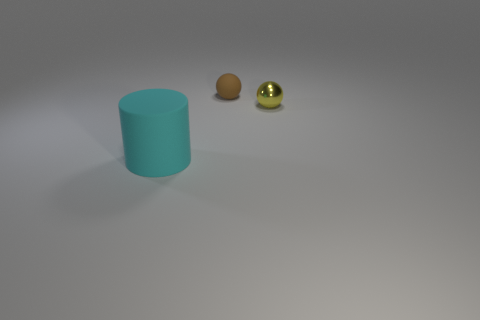What is the size of the cyan object?
Make the answer very short. Large. What number of things are either yellow metal spheres or tiny brown spheres?
Your answer should be very brief. 2. There is a object that is right of the rubber sphere; what size is it?
Your answer should be very brief. Small. Is there anything else that is the same size as the cyan cylinder?
Your answer should be compact. No. There is a thing that is both to the left of the small yellow shiny thing and to the right of the large cyan thing; what is its color?
Your answer should be compact. Brown. Is the material of the tiny object that is in front of the tiny brown matte sphere the same as the big cyan object?
Provide a short and direct response. No. Does the large rubber cylinder have the same color as the rubber object that is right of the cyan rubber cylinder?
Provide a short and direct response. No. Are there any things on the left side of the small brown ball?
Your response must be concise. Yes. There is a rubber object that is to the right of the rubber cylinder; does it have the same size as the cyan matte thing on the left side of the yellow shiny sphere?
Ensure brevity in your answer.  No. Is there a yellow shiny thing of the same size as the brown matte thing?
Provide a short and direct response. Yes. 